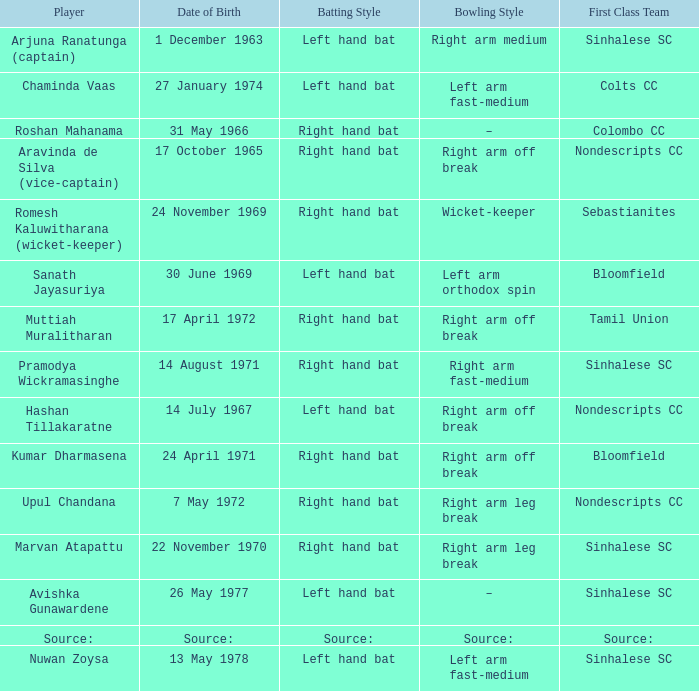Who has a bowling style of source:? Source:. 